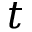Convert formula to latex. <formula><loc_0><loc_0><loc_500><loc_500>t</formula> 